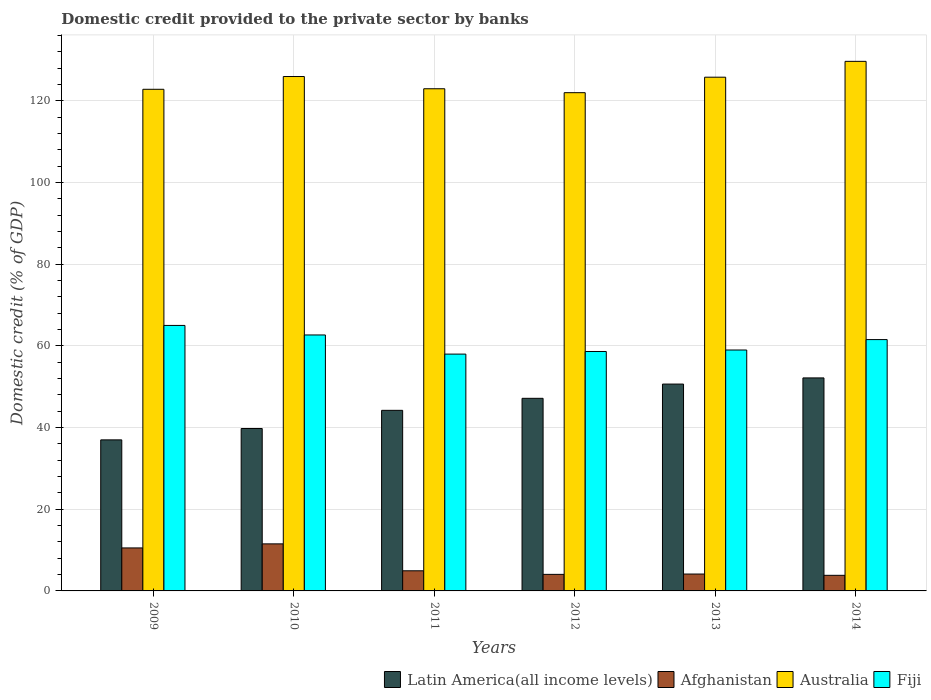How many bars are there on the 3rd tick from the left?
Offer a terse response. 4. What is the label of the 5th group of bars from the left?
Provide a short and direct response. 2013. In how many cases, is the number of bars for a given year not equal to the number of legend labels?
Give a very brief answer. 0. What is the domestic credit provided to the private sector by banks in Afghanistan in 2011?
Ensure brevity in your answer.  4.93. Across all years, what is the maximum domestic credit provided to the private sector by banks in Australia?
Your answer should be very brief. 129.64. Across all years, what is the minimum domestic credit provided to the private sector by banks in Latin America(all income levels)?
Your answer should be compact. 36.98. In which year was the domestic credit provided to the private sector by banks in Latin America(all income levels) maximum?
Offer a very short reply. 2014. What is the total domestic credit provided to the private sector by banks in Australia in the graph?
Ensure brevity in your answer.  749.01. What is the difference between the domestic credit provided to the private sector by banks in Latin America(all income levels) in 2010 and that in 2012?
Offer a very short reply. -7.39. What is the difference between the domestic credit provided to the private sector by banks in Afghanistan in 2011 and the domestic credit provided to the private sector by banks in Latin America(all income levels) in 2010?
Keep it short and to the point. -34.83. What is the average domestic credit provided to the private sector by banks in Fiji per year?
Keep it short and to the point. 60.79. In the year 2010, what is the difference between the domestic credit provided to the private sector by banks in Afghanistan and domestic credit provided to the private sector by banks in Latin America(all income levels)?
Your answer should be very brief. -28.24. What is the ratio of the domestic credit provided to the private sector by banks in Fiji in 2011 to that in 2014?
Your answer should be very brief. 0.94. Is the domestic credit provided to the private sector by banks in Afghanistan in 2009 less than that in 2010?
Offer a terse response. Yes. Is the difference between the domestic credit provided to the private sector by banks in Afghanistan in 2011 and 2014 greater than the difference between the domestic credit provided to the private sector by banks in Latin America(all income levels) in 2011 and 2014?
Give a very brief answer. Yes. What is the difference between the highest and the second highest domestic credit provided to the private sector by banks in Fiji?
Your answer should be very brief. 2.33. What is the difference between the highest and the lowest domestic credit provided to the private sector by banks in Latin America(all income levels)?
Give a very brief answer. 15.17. In how many years, is the domestic credit provided to the private sector by banks in Afghanistan greater than the average domestic credit provided to the private sector by banks in Afghanistan taken over all years?
Provide a short and direct response. 2. Is it the case that in every year, the sum of the domestic credit provided to the private sector by banks in Latin America(all income levels) and domestic credit provided to the private sector by banks in Australia is greater than the sum of domestic credit provided to the private sector by banks in Fiji and domestic credit provided to the private sector by banks in Afghanistan?
Ensure brevity in your answer.  Yes. What does the 2nd bar from the left in 2014 represents?
Your answer should be very brief. Afghanistan. What does the 4th bar from the right in 2009 represents?
Your answer should be very brief. Latin America(all income levels). Is it the case that in every year, the sum of the domestic credit provided to the private sector by banks in Australia and domestic credit provided to the private sector by banks in Afghanistan is greater than the domestic credit provided to the private sector by banks in Latin America(all income levels)?
Provide a short and direct response. Yes. How many bars are there?
Your response must be concise. 24. Are all the bars in the graph horizontal?
Your response must be concise. No. How many years are there in the graph?
Keep it short and to the point. 6. What is the difference between two consecutive major ticks on the Y-axis?
Make the answer very short. 20. Does the graph contain grids?
Provide a succinct answer. Yes. What is the title of the graph?
Ensure brevity in your answer.  Domestic credit provided to the private sector by banks. What is the label or title of the X-axis?
Keep it short and to the point. Years. What is the label or title of the Y-axis?
Your answer should be compact. Domestic credit (% of GDP). What is the Domestic credit (% of GDP) of Latin America(all income levels) in 2009?
Offer a terse response. 36.98. What is the Domestic credit (% of GDP) of Afghanistan in 2009?
Provide a short and direct response. 10.53. What is the Domestic credit (% of GDP) of Australia in 2009?
Provide a succinct answer. 122.8. What is the Domestic credit (% of GDP) in Fiji in 2009?
Your response must be concise. 64.99. What is the Domestic credit (% of GDP) in Latin America(all income levels) in 2010?
Your answer should be compact. 39.76. What is the Domestic credit (% of GDP) in Afghanistan in 2010?
Give a very brief answer. 11.52. What is the Domestic credit (% of GDP) of Australia in 2010?
Give a very brief answer. 125.92. What is the Domestic credit (% of GDP) of Fiji in 2010?
Your response must be concise. 62.66. What is the Domestic credit (% of GDP) in Latin America(all income levels) in 2011?
Give a very brief answer. 44.21. What is the Domestic credit (% of GDP) of Afghanistan in 2011?
Your response must be concise. 4.93. What is the Domestic credit (% of GDP) of Australia in 2011?
Ensure brevity in your answer.  122.93. What is the Domestic credit (% of GDP) of Fiji in 2011?
Keep it short and to the point. 57.97. What is the Domestic credit (% of GDP) of Latin America(all income levels) in 2012?
Make the answer very short. 47.15. What is the Domestic credit (% of GDP) in Afghanistan in 2012?
Offer a terse response. 4.05. What is the Domestic credit (% of GDP) of Australia in 2012?
Ensure brevity in your answer.  121.97. What is the Domestic credit (% of GDP) of Fiji in 2012?
Your answer should be compact. 58.61. What is the Domestic credit (% of GDP) in Latin America(all income levels) in 2013?
Provide a succinct answer. 50.63. What is the Domestic credit (% of GDP) in Afghanistan in 2013?
Provide a short and direct response. 4.13. What is the Domestic credit (% of GDP) of Australia in 2013?
Keep it short and to the point. 125.76. What is the Domestic credit (% of GDP) in Fiji in 2013?
Offer a terse response. 58.97. What is the Domestic credit (% of GDP) of Latin America(all income levels) in 2014?
Give a very brief answer. 52.14. What is the Domestic credit (% of GDP) in Afghanistan in 2014?
Ensure brevity in your answer.  3.82. What is the Domestic credit (% of GDP) of Australia in 2014?
Provide a succinct answer. 129.64. What is the Domestic credit (% of GDP) in Fiji in 2014?
Give a very brief answer. 61.52. Across all years, what is the maximum Domestic credit (% of GDP) in Latin America(all income levels)?
Your answer should be compact. 52.14. Across all years, what is the maximum Domestic credit (% of GDP) in Afghanistan?
Make the answer very short. 11.52. Across all years, what is the maximum Domestic credit (% of GDP) in Australia?
Ensure brevity in your answer.  129.64. Across all years, what is the maximum Domestic credit (% of GDP) of Fiji?
Provide a short and direct response. 64.99. Across all years, what is the minimum Domestic credit (% of GDP) in Latin America(all income levels)?
Give a very brief answer. 36.98. Across all years, what is the minimum Domestic credit (% of GDP) in Afghanistan?
Ensure brevity in your answer.  3.82. Across all years, what is the minimum Domestic credit (% of GDP) in Australia?
Keep it short and to the point. 121.97. Across all years, what is the minimum Domestic credit (% of GDP) of Fiji?
Your answer should be very brief. 57.97. What is the total Domestic credit (% of GDP) of Latin America(all income levels) in the graph?
Ensure brevity in your answer.  270.86. What is the total Domestic credit (% of GDP) in Afghanistan in the graph?
Your answer should be very brief. 38.98. What is the total Domestic credit (% of GDP) of Australia in the graph?
Provide a succinct answer. 749.01. What is the total Domestic credit (% of GDP) in Fiji in the graph?
Your response must be concise. 364.73. What is the difference between the Domestic credit (% of GDP) of Latin America(all income levels) in 2009 and that in 2010?
Provide a succinct answer. -2.78. What is the difference between the Domestic credit (% of GDP) of Afghanistan in 2009 and that in 2010?
Provide a short and direct response. -0.99. What is the difference between the Domestic credit (% of GDP) of Australia in 2009 and that in 2010?
Provide a succinct answer. -3.13. What is the difference between the Domestic credit (% of GDP) of Fiji in 2009 and that in 2010?
Provide a short and direct response. 2.33. What is the difference between the Domestic credit (% of GDP) in Latin America(all income levels) in 2009 and that in 2011?
Your response must be concise. -7.23. What is the difference between the Domestic credit (% of GDP) in Afghanistan in 2009 and that in 2011?
Offer a very short reply. 5.6. What is the difference between the Domestic credit (% of GDP) of Australia in 2009 and that in 2011?
Offer a very short reply. -0.13. What is the difference between the Domestic credit (% of GDP) in Fiji in 2009 and that in 2011?
Offer a very short reply. 7.02. What is the difference between the Domestic credit (% of GDP) of Latin America(all income levels) in 2009 and that in 2012?
Provide a succinct answer. -10.17. What is the difference between the Domestic credit (% of GDP) in Afghanistan in 2009 and that in 2012?
Keep it short and to the point. 6.47. What is the difference between the Domestic credit (% of GDP) in Australia in 2009 and that in 2012?
Give a very brief answer. 0.83. What is the difference between the Domestic credit (% of GDP) of Fiji in 2009 and that in 2012?
Ensure brevity in your answer.  6.38. What is the difference between the Domestic credit (% of GDP) of Latin America(all income levels) in 2009 and that in 2013?
Keep it short and to the point. -13.66. What is the difference between the Domestic credit (% of GDP) in Afghanistan in 2009 and that in 2013?
Provide a short and direct response. 6.39. What is the difference between the Domestic credit (% of GDP) of Australia in 2009 and that in 2013?
Give a very brief answer. -2.96. What is the difference between the Domestic credit (% of GDP) of Fiji in 2009 and that in 2013?
Your response must be concise. 6.02. What is the difference between the Domestic credit (% of GDP) of Latin America(all income levels) in 2009 and that in 2014?
Provide a short and direct response. -15.17. What is the difference between the Domestic credit (% of GDP) of Afghanistan in 2009 and that in 2014?
Keep it short and to the point. 6.71. What is the difference between the Domestic credit (% of GDP) of Australia in 2009 and that in 2014?
Give a very brief answer. -6.84. What is the difference between the Domestic credit (% of GDP) in Fiji in 2009 and that in 2014?
Give a very brief answer. 3.47. What is the difference between the Domestic credit (% of GDP) of Latin America(all income levels) in 2010 and that in 2011?
Ensure brevity in your answer.  -4.45. What is the difference between the Domestic credit (% of GDP) of Afghanistan in 2010 and that in 2011?
Your answer should be very brief. 6.59. What is the difference between the Domestic credit (% of GDP) of Australia in 2010 and that in 2011?
Offer a very short reply. 3. What is the difference between the Domestic credit (% of GDP) in Fiji in 2010 and that in 2011?
Offer a terse response. 4.68. What is the difference between the Domestic credit (% of GDP) in Latin America(all income levels) in 2010 and that in 2012?
Your answer should be compact. -7.39. What is the difference between the Domestic credit (% of GDP) of Afghanistan in 2010 and that in 2012?
Your answer should be very brief. 7.46. What is the difference between the Domestic credit (% of GDP) of Australia in 2010 and that in 2012?
Your answer should be very brief. 3.95. What is the difference between the Domestic credit (% of GDP) in Fiji in 2010 and that in 2012?
Your answer should be very brief. 4.05. What is the difference between the Domestic credit (% of GDP) in Latin America(all income levels) in 2010 and that in 2013?
Provide a succinct answer. -10.88. What is the difference between the Domestic credit (% of GDP) in Afghanistan in 2010 and that in 2013?
Your answer should be very brief. 7.39. What is the difference between the Domestic credit (% of GDP) of Australia in 2010 and that in 2013?
Your answer should be compact. 0.16. What is the difference between the Domestic credit (% of GDP) in Fiji in 2010 and that in 2013?
Provide a short and direct response. 3.68. What is the difference between the Domestic credit (% of GDP) in Latin America(all income levels) in 2010 and that in 2014?
Provide a short and direct response. -12.39. What is the difference between the Domestic credit (% of GDP) in Afghanistan in 2010 and that in 2014?
Offer a terse response. 7.7. What is the difference between the Domestic credit (% of GDP) in Australia in 2010 and that in 2014?
Offer a terse response. -3.71. What is the difference between the Domestic credit (% of GDP) in Fiji in 2010 and that in 2014?
Keep it short and to the point. 1.13. What is the difference between the Domestic credit (% of GDP) in Latin America(all income levels) in 2011 and that in 2012?
Provide a short and direct response. -2.94. What is the difference between the Domestic credit (% of GDP) of Australia in 2011 and that in 2012?
Keep it short and to the point. 0.96. What is the difference between the Domestic credit (% of GDP) in Fiji in 2011 and that in 2012?
Your answer should be compact. -0.64. What is the difference between the Domestic credit (% of GDP) of Latin America(all income levels) in 2011 and that in 2013?
Your response must be concise. -6.43. What is the difference between the Domestic credit (% of GDP) in Afghanistan in 2011 and that in 2013?
Keep it short and to the point. 0.8. What is the difference between the Domestic credit (% of GDP) of Australia in 2011 and that in 2013?
Your answer should be very brief. -2.83. What is the difference between the Domestic credit (% of GDP) of Fiji in 2011 and that in 2013?
Ensure brevity in your answer.  -1. What is the difference between the Domestic credit (% of GDP) of Latin America(all income levels) in 2011 and that in 2014?
Make the answer very short. -7.94. What is the difference between the Domestic credit (% of GDP) in Afghanistan in 2011 and that in 2014?
Your response must be concise. 1.11. What is the difference between the Domestic credit (% of GDP) in Australia in 2011 and that in 2014?
Provide a succinct answer. -6.71. What is the difference between the Domestic credit (% of GDP) of Fiji in 2011 and that in 2014?
Your response must be concise. -3.55. What is the difference between the Domestic credit (% of GDP) of Latin America(all income levels) in 2012 and that in 2013?
Your response must be concise. -3.49. What is the difference between the Domestic credit (% of GDP) of Afghanistan in 2012 and that in 2013?
Your answer should be very brief. -0.08. What is the difference between the Domestic credit (% of GDP) in Australia in 2012 and that in 2013?
Make the answer very short. -3.79. What is the difference between the Domestic credit (% of GDP) of Fiji in 2012 and that in 2013?
Provide a succinct answer. -0.36. What is the difference between the Domestic credit (% of GDP) of Latin America(all income levels) in 2012 and that in 2014?
Offer a very short reply. -5. What is the difference between the Domestic credit (% of GDP) of Afghanistan in 2012 and that in 2014?
Provide a short and direct response. 0.24. What is the difference between the Domestic credit (% of GDP) in Australia in 2012 and that in 2014?
Make the answer very short. -7.67. What is the difference between the Domestic credit (% of GDP) of Fiji in 2012 and that in 2014?
Ensure brevity in your answer.  -2.91. What is the difference between the Domestic credit (% of GDP) of Latin America(all income levels) in 2013 and that in 2014?
Offer a terse response. -1.51. What is the difference between the Domestic credit (% of GDP) in Afghanistan in 2013 and that in 2014?
Your answer should be very brief. 0.31. What is the difference between the Domestic credit (% of GDP) in Australia in 2013 and that in 2014?
Provide a succinct answer. -3.88. What is the difference between the Domestic credit (% of GDP) in Fiji in 2013 and that in 2014?
Keep it short and to the point. -2.55. What is the difference between the Domestic credit (% of GDP) of Latin America(all income levels) in 2009 and the Domestic credit (% of GDP) of Afghanistan in 2010?
Your answer should be compact. 25.46. What is the difference between the Domestic credit (% of GDP) of Latin America(all income levels) in 2009 and the Domestic credit (% of GDP) of Australia in 2010?
Your answer should be compact. -88.95. What is the difference between the Domestic credit (% of GDP) of Latin America(all income levels) in 2009 and the Domestic credit (% of GDP) of Fiji in 2010?
Your answer should be very brief. -25.68. What is the difference between the Domestic credit (% of GDP) of Afghanistan in 2009 and the Domestic credit (% of GDP) of Australia in 2010?
Provide a succinct answer. -115.4. What is the difference between the Domestic credit (% of GDP) of Afghanistan in 2009 and the Domestic credit (% of GDP) of Fiji in 2010?
Provide a short and direct response. -52.13. What is the difference between the Domestic credit (% of GDP) of Australia in 2009 and the Domestic credit (% of GDP) of Fiji in 2010?
Keep it short and to the point. 60.14. What is the difference between the Domestic credit (% of GDP) of Latin America(all income levels) in 2009 and the Domestic credit (% of GDP) of Afghanistan in 2011?
Make the answer very short. 32.05. What is the difference between the Domestic credit (% of GDP) of Latin America(all income levels) in 2009 and the Domestic credit (% of GDP) of Australia in 2011?
Keep it short and to the point. -85.95. What is the difference between the Domestic credit (% of GDP) in Latin America(all income levels) in 2009 and the Domestic credit (% of GDP) in Fiji in 2011?
Your response must be concise. -21. What is the difference between the Domestic credit (% of GDP) in Afghanistan in 2009 and the Domestic credit (% of GDP) in Australia in 2011?
Offer a terse response. -112.4. What is the difference between the Domestic credit (% of GDP) of Afghanistan in 2009 and the Domestic credit (% of GDP) of Fiji in 2011?
Provide a short and direct response. -47.45. What is the difference between the Domestic credit (% of GDP) in Australia in 2009 and the Domestic credit (% of GDP) in Fiji in 2011?
Provide a succinct answer. 64.82. What is the difference between the Domestic credit (% of GDP) in Latin America(all income levels) in 2009 and the Domestic credit (% of GDP) in Afghanistan in 2012?
Offer a terse response. 32.92. What is the difference between the Domestic credit (% of GDP) in Latin America(all income levels) in 2009 and the Domestic credit (% of GDP) in Australia in 2012?
Your answer should be compact. -84.99. What is the difference between the Domestic credit (% of GDP) of Latin America(all income levels) in 2009 and the Domestic credit (% of GDP) of Fiji in 2012?
Offer a terse response. -21.63. What is the difference between the Domestic credit (% of GDP) of Afghanistan in 2009 and the Domestic credit (% of GDP) of Australia in 2012?
Your answer should be very brief. -111.44. What is the difference between the Domestic credit (% of GDP) in Afghanistan in 2009 and the Domestic credit (% of GDP) in Fiji in 2012?
Make the answer very short. -48.08. What is the difference between the Domestic credit (% of GDP) in Australia in 2009 and the Domestic credit (% of GDP) in Fiji in 2012?
Offer a very short reply. 64.19. What is the difference between the Domestic credit (% of GDP) in Latin America(all income levels) in 2009 and the Domestic credit (% of GDP) in Afghanistan in 2013?
Your answer should be compact. 32.84. What is the difference between the Domestic credit (% of GDP) in Latin America(all income levels) in 2009 and the Domestic credit (% of GDP) in Australia in 2013?
Offer a very short reply. -88.78. What is the difference between the Domestic credit (% of GDP) of Latin America(all income levels) in 2009 and the Domestic credit (% of GDP) of Fiji in 2013?
Offer a terse response. -22. What is the difference between the Domestic credit (% of GDP) in Afghanistan in 2009 and the Domestic credit (% of GDP) in Australia in 2013?
Your answer should be compact. -115.23. What is the difference between the Domestic credit (% of GDP) in Afghanistan in 2009 and the Domestic credit (% of GDP) in Fiji in 2013?
Give a very brief answer. -48.45. What is the difference between the Domestic credit (% of GDP) in Australia in 2009 and the Domestic credit (% of GDP) in Fiji in 2013?
Your answer should be very brief. 63.82. What is the difference between the Domestic credit (% of GDP) in Latin America(all income levels) in 2009 and the Domestic credit (% of GDP) in Afghanistan in 2014?
Ensure brevity in your answer.  33.16. What is the difference between the Domestic credit (% of GDP) in Latin America(all income levels) in 2009 and the Domestic credit (% of GDP) in Australia in 2014?
Offer a terse response. -92.66. What is the difference between the Domestic credit (% of GDP) in Latin America(all income levels) in 2009 and the Domestic credit (% of GDP) in Fiji in 2014?
Your answer should be very brief. -24.55. What is the difference between the Domestic credit (% of GDP) of Afghanistan in 2009 and the Domestic credit (% of GDP) of Australia in 2014?
Your response must be concise. -119.11. What is the difference between the Domestic credit (% of GDP) of Afghanistan in 2009 and the Domestic credit (% of GDP) of Fiji in 2014?
Ensure brevity in your answer.  -51. What is the difference between the Domestic credit (% of GDP) of Australia in 2009 and the Domestic credit (% of GDP) of Fiji in 2014?
Provide a short and direct response. 61.27. What is the difference between the Domestic credit (% of GDP) of Latin America(all income levels) in 2010 and the Domestic credit (% of GDP) of Afghanistan in 2011?
Provide a succinct answer. 34.83. What is the difference between the Domestic credit (% of GDP) of Latin America(all income levels) in 2010 and the Domestic credit (% of GDP) of Australia in 2011?
Provide a succinct answer. -83.17. What is the difference between the Domestic credit (% of GDP) in Latin America(all income levels) in 2010 and the Domestic credit (% of GDP) in Fiji in 2011?
Your answer should be compact. -18.22. What is the difference between the Domestic credit (% of GDP) in Afghanistan in 2010 and the Domestic credit (% of GDP) in Australia in 2011?
Your answer should be compact. -111.41. What is the difference between the Domestic credit (% of GDP) of Afghanistan in 2010 and the Domestic credit (% of GDP) of Fiji in 2011?
Your response must be concise. -46.46. What is the difference between the Domestic credit (% of GDP) in Australia in 2010 and the Domestic credit (% of GDP) in Fiji in 2011?
Your answer should be compact. 67.95. What is the difference between the Domestic credit (% of GDP) in Latin America(all income levels) in 2010 and the Domestic credit (% of GDP) in Afghanistan in 2012?
Your answer should be very brief. 35.7. What is the difference between the Domestic credit (% of GDP) of Latin America(all income levels) in 2010 and the Domestic credit (% of GDP) of Australia in 2012?
Provide a succinct answer. -82.21. What is the difference between the Domestic credit (% of GDP) in Latin America(all income levels) in 2010 and the Domestic credit (% of GDP) in Fiji in 2012?
Ensure brevity in your answer.  -18.85. What is the difference between the Domestic credit (% of GDP) in Afghanistan in 2010 and the Domestic credit (% of GDP) in Australia in 2012?
Make the answer very short. -110.45. What is the difference between the Domestic credit (% of GDP) of Afghanistan in 2010 and the Domestic credit (% of GDP) of Fiji in 2012?
Provide a succinct answer. -47.09. What is the difference between the Domestic credit (% of GDP) of Australia in 2010 and the Domestic credit (% of GDP) of Fiji in 2012?
Give a very brief answer. 67.31. What is the difference between the Domestic credit (% of GDP) in Latin America(all income levels) in 2010 and the Domestic credit (% of GDP) in Afghanistan in 2013?
Offer a very short reply. 35.62. What is the difference between the Domestic credit (% of GDP) of Latin America(all income levels) in 2010 and the Domestic credit (% of GDP) of Australia in 2013?
Your response must be concise. -86. What is the difference between the Domestic credit (% of GDP) of Latin America(all income levels) in 2010 and the Domestic credit (% of GDP) of Fiji in 2013?
Make the answer very short. -19.22. What is the difference between the Domestic credit (% of GDP) of Afghanistan in 2010 and the Domestic credit (% of GDP) of Australia in 2013?
Your answer should be very brief. -114.24. What is the difference between the Domestic credit (% of GDP) in Afghanistan in 2010 and the Domestic credit (% of GDP) in Fiji in 2013?
Keep it short and to the point. -47.46. What is the difference between the Domestic credit (% of GDP) of Australia in 2010 and the Domestic credit (% of GDP) of Fiji in 2013?
Keep it short and to the point. 66.95. What is the difference between the Domestic credit (% of GDP) in Latin America(all income levels) in 2010 and the Domestic credit (% of GDP) in Afghanistan in 2014?
Offer a terse response. 35.94. What is the difference between the Domestic credit (% of GDP) of Latin America(all income levels) in 2010 and the Domestic credit (% of GDP) of Australia in 2014?
Your answer should be compact. -89.88. What is the difference between the Domestic credit (% of GDP) of Latin America(all income levels) in 2010 and the Domestic credit (% of GDP) of Fiji in 2014?
Provide a succinct answer. -21.77. What is the difference between the Domestic credit (% of GDP) of Afghanistan in 2010 and the Domestic credit (% of GDP) of Australia in 2014?
Your answer should be very brief. -118.12. What is the difference between the Domestic credit (% of GDP) in Afghanistan in 2010 and the Domestic credit (% of GDP) in Fiji in 2014?
Provide a succinct answer. -50.01. What is the difference between the Domestic credit (% of GDP) in Australia in 2010 and the Domestic credit (% of GDP) in Fiji in 2014?
Your answer should be compact. 64.4. What is the difference between the Domestic credit (% of GDP) of Latin America(all income levels) in 2011 and the Domestic credit (% of GDP) of Afghanistan in 2012?
Provide a short and direct response. 40.15. What is the difference between the Domestic credit (% of GDP) of Latin America(all income levels) in 2011 and the Domestic credit (% of GDP) of Australia in 2012?
Give a very brief answer. -77.76. What is the difference between the Domestic credit (% of GDP) in Latin America(all income levels) in 2011 and the Domestic credit (% of GDP) in Fiji in 2012?
Ensure brevity in your answer.  -14.4. What is the difference between the Domestic credit (% of GDP) of Afghanistan in 2011 and the Domestic credit (% of GDP) of Australia in 2012?
Ensure brevity in your answer.  -117.04. What is the difference between the Domestic credit (% of GDP) in Afghanistan in 2011 and the Domestic credit (% of GDP) in Fiji in 2012?
Ensure brevity in your answer.  -53.68. What is the difference between the Domestic credit (% of GDP) of Australia in 2011 and the Domestic credit (% of GDP) of Fiji in 2012?
Keep it short and to the point. 64.32. What is the difference between the Domestic credit (% of GDP) in Latin America(all income levels) in 2011 and the Domestic credit (% of GDP) in Afghanistan in 2013?
Provide a short and direct response. 40.08. What is the difference between the Domestic credit (% of GDP) in Latin America(all income levels) in 2011 and the Domestic credit (% of GDP) in Australia in 2013?
Your answer should be compact. -81.55. What is the difference between the Domestic credit (% of GDP) in Latin America(all income levels) in 2011 and the Domestic credit (% of GDP) in Fiji in 2013?
Give a very brief answer. -14.77. What is the difference between the Domestic credit (% of GDP) in Afghanistan in 2011 and the Domestic credit (% of GDP) in Australia in 2013?
Give a very brief answer. -120.83. What is the difference between the Domestic credit (% of GDP) in Afghanistan in 2011 and the Domestic credit (% of GDP) in Fiji in 2013?
Your answer should be very brief. -54.04. What is the difference between the Domestic credit (% of GDP) of Australia in 2011 and the Domestic credit (% of GDP) of Fiji in 2013?
Your answer should be compact. 63.95. What is the difference between the Domestic credit (% of GDP) in Latin America(all income levels) in 2011 and the Domestic credit (% of GDP) in Afghanistan in 2014?
Your response must be concise. 40.39. What is the difference between the Domestic credit (% of GDP) in Latin America(all income levels) in 2011 and the Domestic credit (% of GDP) in Australia in 2014?
Provide a succinct answer. -85.43. What is the difference between the Domestic credit (% of GDP) of Latin America(all income levels) in 2011 and the Domestic credit (% of GDP) of Fiji in 2014?
Keep it short and to the point. -17.32. What is the difference between the Domestic credit (% of GDP) of Afghanistan in 2011 and the Domestic credit (% of GDP) of Australia in 2014?
Offer a terse response. -124.71. What is the difference between the Domestic credit (% of GDP) of Afghanistan in 2011 and the Domestic credit (% of GDP) of Fiji in 2014?
Offer a very short reply. -56.59. What is the difference between the Domestic credit (% of GDP) in Australia in 2011 and the Domestic credit (% of GDP) in Fiji in 2014?
Offer a very short reply. 61.4. What is the difference between the Domestic credit (% of GDP) of Latin America(all income levels) in 2012 and the Domestic credit (% of GDP) of Afghanistan in 2013?
Your answer should be very brief. 43.01. What is the difference between the Domestic credit (% of GDP) of Latin America(all income levels) in 2012 and the Domestic credit (% of GDP) of Australia in 2013?
Provide a short and direct response. -78.61. What is the difference between the Domestic credit (% of GDP) of Latin America(all income levels) in 2012 and the Domestic credit (% of GDP) of Fiji in 2013?
Ensure brevity in your answer.  -11.83. What is the difference between the Domestic credit (% of GDP) in Afghanistan in 2012 and the Domestic credit (% of GDP) in Australia in 2013?
Offer a terse response. -121.7. What is the difference between the Domestic credit (% of GDP) of Afghanistan in 2012 and the Domestic credit (% of GDP) of Fiji in 2013?
Give a very brief answer. -54.92. What is the difference between the Domestic credit (% of GDP) of Australia in 2012 and the Domestic credit (% of GDP) of Fiji in 2013?
Your answer should be compact. 62.99. What is the difference between the Domestic credit (% of GDP) of Latin America(all income levels) in 2012 and the Domestic credit (% of GDP) of Afghanistan in 2014?
Your answer should be very brief. 43.33. What is the difference between the Domestic credit (% of GDP) in Latin America(all income levels) in 2012 and the Domestic credit (% of GDP) in Australia in 2014?
Provide a succinct answer. -82.49. What is the difference between the Domestic credit (% of GDP) in Latin America(all income levels) in 2012 and the Domestic credit (% of GDP) in Fiji in 2014?
Make the answer very short. -14.38. What is the difference between the Domestic credit (% of GDP) of Afghanistan in 2012 and the Domestic credit (% of GDP) of Australia in 2014?
Your answer should be compact. -125.58. What is the difference between the Domestic credit (% of GDP) of Afghanistan in 2012 and the Domestic credit (% of GDP) of Fiji in 2014?
Offer a very short reply. -57.47. What is the difference between the Domestic credit (% of GDP) in Australia in 2012 and the Domestic credit (% of GDP) in Fiji in 2014?
Ensure brevity in your answer.  60.44. What is the difference between the Domestic credit (% of GDP) in Latin America(all income levels) in 2013 and the Domestic credit (% of GDP) in Afghanistan in 2014?
Your answer should be compact. 46.82. What is the difference between the Domestic credit (% of GDP) of Latin America(all income levels) in 2013 and the Domestic credit (% of GDP) of Australia in 2014?
Provide a succinct answer. -79. What is the difference between the Domestic credit (% of GDP) in Latin America(all income levels) in 2013 and the Domestic credit (% of GDP) in Fiji in 2014?
Offer a very short reply. -10.89. What is the difference between the Domestic credit (% of GDP) of Afghanistan in 2013 and the Domestic credit (% of GDP) of Australia in 2014?
Ensure brevity in your answer.  -125.5. What is the difference between the Domestic credit (% of GDP) in Afghanistan in 2013 and the Domestic credit (% of GDP) in Fiji in 2014?
Offer a very short reply. -57.39. What is the difference between the Domestic credit (% of GDP) in Australia in 2013 and the Domestic credit (% of GDP) in Fiji in 2014?
Offer a terse response. 64.23. What is the average Domestic credit (% of GDP) of Latin America(all income levels) per year?
Ensure brevity in your answer.  45.14. What is the average Domestic credit (% of GDP) in Afghanistan per year?
Your response must be concise. 6.5. What is the average Domestic credit (% of GDP) of Australia per year?
Provide a short and direct response. 124.83. What is the average Domestic credit (% of GDP) of Fiji per year?
Offer a terse response. 60.79. In the year 2009, what is the difference between the Domestic credit (% of GDP) in Latin America(all income levels) and Domestic credit (% of GDP) in Afghanistan?
Your answer should be compact. 26.45. In the year 2009, what is the difference between the Domestic credit (% of GDP) in Latin America(all income levels) and Domestic credit (% of GDP) in Australia?
Offer a very short reply. -85.82. In the year 2009, what is the difference between the Domestic credit (% of GDP) in Latin America(all income levels) and Domestic credit (% of GDP) in Fiji?
Give a very brief answer. -28.02. In the year 2009, what is the difference between the Domestic credit (% of GDP) of Afghanistan and Domestic credit (% of GDP) of Australia?
Make the answer very short. -112.27. In the year 2009, what is the difference between the Domestic credit (% of GDP) in Afghanistan and Domestic credit (% of GDP) in Fiji?
Give a very brief answer. -54.47. In the year 2009, what is the difference between the Domestic credit (% of GDP) in Australia and Domestic credit (% of GDP) in Fiji?
Your answer should be compact. 57.81. In the year 2010, what is the difference between the Domestic credit (% of GDP) in Latin America(all income levels) and Domestic credit (% of GDP) in Afghanistan?
Ensure brevity in your answer.  28.24. In the year 2010, what is the difference between the Domestic credit (% of GDP) in Latin America(all income levels) and Domestic credit (% of GDP) in Australia?
Make the answer very short. -86.17. In the year 2010, what is the difference between the Domestic credit (% of GDP) in Latin America(all income levels) and Domestic credit (% of GDP) in Fiji?
Your answer should be very brief. -22.9. In the year 2010, what is the difference between the Domestic credit (% of GDP) of Afghanistan and Domestic credit (% of GDP) of Australia?
Keep it short and to the point. -114.41. In the year 2010, what is the difference between the Domestic credit (% of GDP) in Afghanistan and Domestic credit (% of GDP) in Fiji?
Your answer should be compact. -51.14. In the year 2010, what is the difference between the Domestic credit (% of GDP) in Australia and Domestic credit (% of GDP) in Fiji?
Your answer should be very brief. 63.26. In the year 2011, what is the difference between the Domestic credit (% of GDP) in Latin America(all income levels) and Domestic credit (% of GDP) in Afghanistan?
Offer a very short reply. 39.28. In the year 2011, what is the difference between the Domestic credit (% of GDP) of Latin America(all income levels) and Domestic credit (% of GDP) of Australia?
Provide a succinct answer. -78.72. In the year 2011, what is the difference between the Domestic credit (% of GDP) in Latin America(all income levels) and Domestic credit (% of GDP) in Fiji?
Give a very brief answer. -13.77. In the year 2011, what is the difference between the Domestic credit (% of GDP) in Afghanistan and Domestic credit (% of GDP) in Australia?
Your response must be concise. -118. In the year 2011, what is the difference between the Domestic credit (% of GDP) in Afghanistan and Domestic credit (% of GDP) in Fiji?
Offer a terse response. -53.04. In the year 2011, what is the difference between the Domestic credit (% of GDP) in Australia and Domestic credit (% of GDP) in Fiji?
Offer a very short reply. 64.95. In the year 2012, what is the difference between the Domestic credit (% of GDP) in Latin America(all income levels) and Domestic credit (% of GDP) in Afghanistan?
Offer a terse response. 43.09. In the year 2012, what is the difference between the Domestic credit (% of GDP) in Latin America(all income levels) and Domestic credit (% of GDP) in Australia?
Make the answer very short. -74.82. In the year 2012, what is the difference between the Domestic credit (% of GDP) of Latin America(all income levels) and Domestic credit (% of GDP) of Fiji?
Offer a terse response. -11.46. In the year 2012, what is the difference between the Domestic credit (% of GDP) in Afghanistan and Domestic credit (% of GDP) in Australia?
Provide a succinct answer. -117.91. In the year 2012, what is the difference between the Domestic credit (% of GDP) of Afghanistan and Domestic credit (% of GDP) of Fiji?
Your response must be concise. -54.56. In the year 2012, what is the difference between the Domestic credit (% of GDP) in Australia and Domestic credit (% of GDP) in Fiji?
Your answer should be very brief. 63.36. In the year 2013, what is the difference between the Domestic credit (% of GDP) of Latin America(all income levels) and Domestic credit (% of GDP) of Afghanistan?
Provide a short and direct response. 46.5. In the year 2013, what is the difference between the Domestic credit (% of GDP) of Latin America(all income levels) and Domestic credit (% of GDP) of Australia?
Provide a short and direct response. -75.12. In the year 2013, what is the difference between the Domestic credit (% of GDP) in Latin America(all income levels) and Domestic credit (% of GDP) in Fiji?
Provide a short and direct response. -8.34. In the year 2013, what is the difference between the Domestic credit (% of GDP) in Afghanistan and Domestic credit (% of GDP) in Australia?
Your response must be concise. -121.63. In the year 2013, what is the difference between the Domestic credit (% of GDP) in Afghanistan and Domestic credit (% of GDP) in Fiji?
Ensure brevity in your answer.  -54.84. In the year 2013, what is the difference between the Domestic credit (% of GDP) in Australia and Domestic credit (% of GDP) in Fiji?
Give a very brief answer. 66.78. In the year 2014, what is the difference between the Domestic credit (% of GDP) in Latin America(all income levels) and Domestic credit (% of GDP) in Afghanistan?
Your answer should be very brief. 48.33. In the year 2014, what is the difference between the Domestic credit (% of GDP) of Latin America(all income levels) and Domestic credit (% of GDP) of Australia?
Provide a succinct answer. -77.49. In the year 2014, what is the difference between the Domestic credit (% of GDP) in Latin America(all income levels) and Domestic credit (% of GDP) in Fiji?
Provide a succinct answer. -9.38. In the year 2014, what is the difference between the Domestic credit (% of GDP) in Afghanistan and Domestic credit (% of GDP) in Australia?
Make the answer very short. -125.82. In the year 2014, what is the difference between the Domestic credit (% of GDP) of Afghanistan and Domestic credit (% of GDP) of Fiji?
Offer a very short reply. -57.71. In the year 2014, what is the difference between the Domestic credit (% of GDP) in Australia and Domestic credit (% of GDP) in Fiji?
Give a very brief answer. 68.11. What is the ratio of the Domestic credit (% of GDP) in Latin America(all income levels) in 2009 to that in 2010?
Keep it short and to the point. 0.93. What is the ratio of the Domestic credit (% of GDP) of Afghanistan in 2009 to that in 2010?
Your answer should be compact. 0.91. What is the ratio of the Domestic credit (% of GDP) of Australia in 2009 to that in 2010?
Provide a short and direct response. 0.98. What is the ratio of the Domestic credit (% of GDP) of Fiji in 2009 to that in 2010?
Ensure brevity in your answer.  1.04. What is the ratio of the Domestic credit (% of GDP) in Latin America(all income levels) in 2009 to that in 2011?
Ensure brevity in your answer.  0.84. What is the ratio of the Domestic credit (% of GDP) in Afghanistan in 2009 to that in 2011?
Offer a terse response. 2.14. What is the ratio of the Domestic credit (% of GDP) in Fiji in 2009 to that in 2011?
Your answer should be compact. 1.12. What is the ratio of the Domestic credit (% of GDP) in Latin America(all income levels) in 2009 to that in 2012?
Offer a very short reply. 0.78. What is the ratio of the Domestic credit (% of GDP) in Afghanistan in 2009 to that in 2012?
Ensure brevity in your answer.  2.6. What is the ratio of the Domestic credit (% of GDP) of Australia in 2009 to that in 2012?
Your response must be concise. 1.01. What is the ratio of the Domestic credit (% of GDP) of Fiji in 2009 to that in 2012?
Keep it short and to the point. 1.11. What is the ratio of the Domestic credit (% of GDP) of Latin America(all income levels) in 2009 to that in 2013?
Keep it short and to the point. 0.73. What is the ratio of the Domestic credit (% of GDP) of Afghanistan in 2009 to that in 2013?
Ensure brevity in your answer.  2.55. What is the ratio of the Domestic credit (% of GDP) in Australia in 2009 to that in 2013?
Provide a succinct answer. 0.98. What is the ratio of the Domestic credit (% of GDP) of Fiji in 2009 to that in 2013?
Offer a very short reply. 1.1. What is the ratio of the Domestic credit (% of GDP) in Latin America(all income levels) in 2009 to that in 2014?
Provide a succinct answer. 0.71. What is the ratio of the Domestic credit (% of GDP) of Afghanistan in 2009 to that in 2014?
Offer a very short reply. 2.76. What is the ratio of the Domestic credit (% of GDP) in Australia in 2009 to that in 2014?
Keep it short and to the point. 0.95. What is the ratio of the Domestic credit (% of GDP) of Fiji in 2009 to that in 2014?
Offer a terse response. 1.06. What is the ratio of the Domestic credit (% of GDP) of Latin America(all income levels) in 2010 to that in 2011?
Give a very brief answer. 0.9. What is the ratio of the Domestic credit (% of GDP) of Afghanistan in 2010 to that in 2011?
Ensure brevity in your answer.  2.34. What is the ratio of the Domestic credit (% of GDP) in Australia in 2010 to that in 2011?
Keep it short and to the point. 1.02. What is the ratio of the Domestic credit (% of GDP) in Fiji in 2010 to that in 2011?
Your response must be concise. 1.08. What is the ratio of the Domestic credit (% of GDP) of Latin America(all income levels) in 2010 to that in 2012?
Ensure brevity in your answer.  0.84. What is the ratio of the Domestic credit (% of GDP) in Afghanistan in 2010 to that in 2012?
Offer a terse response. 2.84. What is the ratio of the Domestic credit (% of GDP) of Australia in 2010 to that in 2012?
Give a very brief answer. 1.03. What is the ratio of the Domestic credit (% of GDP) of Fiji in 2010 to that in 2012?
Provide a short and direct response. 1.07. What is the ratio of the Domestic credit (% of GDP) in Latin America(all income levels) in 2010 to that in 2013?
Provide a succinct answer. 0.79. What is the ratio of the Domestic credit (% of GDP) in Afghanistan in 2010 to that in 2013?
Offer a very short reply. 2.79. What is the ratio of the Domestic credit (% of GDP) in Australia in 2010 to that in 2013?
Ensure brevity in your answer.  1. What is the ratio of the Domestic credit (% of GDP) of Latin America(all income levels) in 2010 to that in 2014?
Provide a succinct answer. 0.76. What is the ratio of the Domestic credit (% of GDP) of Afghanistan in 2010 to that in 2014?
Provide a short and direct response. 3.02. What is the ratio of the Domestic credit (% of GDP) in Australia in 2010 to that in 2014?
Your answer should be compact. 0.97. What is the ratio of the Domestic credit (% of GDP) of Fiji in 2010 to that in 2014?
Keep it short and to the point. 1.02. What is the ratio of the Domestic credit (% of GDP) of Latin America(all income levels) in 2011 to that in 2012?
Make the answer very short. 0.94. What is the ratio of the Domestic credit (% of GDP) in Afghanistan in 2011 to that in 2012?
Give a very brief answer. 1.22. What is the ratio of the Domestic credit (% of GDP) in Australia in 2011 to that in 2012?
Your response must be concise. 1.01. What is the ratio of the Domestic credit (% of GDP) in Fiji in 2011 to that in 2012?
Offer a terse response. 0.99. What is the ratio of the Domestic credit (% of GDP) in Latin America(all income levels) in 2011 to that in 2013?
Your response must be concise. 0.87. What is the ratio of the Domestic credit (% of GDP) of Afghanistan in 2011 to that in 2013?
Offer a very short reply. 1.19. What is the ratio of the Domestic credit (% of GDP) of Australia in 2011 to that in 2013?
Make the answer very short. 0.98. What is the ratio of the Domestic credit (% of GDP) of Latin America(all income levels) in 2011 to that in 2014?
Offer a very short reply. 0.85. What is the ratio of the Domestic credit (% of GDP) of Afghanistan in 2011 to that in 2014?
Offer a very short reply. 1.29. What is the ratio of the Domestic credit (% of GDP) of Australia in 2011 to that in 2014?
Ensure brevity in your answer.  0.95. What is the ratio of the Domestic credit (% of GDP) in Fiji in 2011 to that in 2014?
Provide a succinct answer. 0.94. What is the ratio of the Domestic credit (% of GDP) of Latin America(all income levels) in 2012 to that in 2013?
Your answer should be compact. 0.93. What is the ratio of the Domestic credit (% of GDP) of Afghanistan in 2012 to that in 2013?
Your response must be concise. 0.98. What is the ratio of the Domestic credit (% of GDP) in Australia in 2012 to that in 2013?
Your response must be concise. 0.97. What is the ratio of the Domestic credit (% of GDP) in Fiji in 2012 to that in 2013?
Provide a short and direct response. 0.99. What is the ratio of the Domestic credit (% of GDP) of Latin America(all income levels) in 2012 to that in 2014?
Your answer should be very brief. 0.9. What is the ratio of the Domestic credit (% of GDP) of Afghanistan in 2012 to that in 2014?
Make the answer very short. 1.06. What is the ratio of the Domestic credit (% of GDP) of Australia in 2012 to that in 2014?
Your response must be concise. 0.94. What is the ratio of the Domestic credit (% of GDP) in Fiji in 2012 to that in 2014?
Make the answer very short. 0.95. What is the ratio of the Domestic credit (% of GDP) in Afghanistan in 2013 to that in 2014?
Your answer should be very brief. 1.08. What is the ratio of the Domestic credit (% of GDP) of Australia in 2013 to that in 2014?
Keep it short and to the point. 0.97. What is the ratio of the Domestic credit (% of GDP) of Fiji in 2013 to that in 2014?
Your answer should be compact. 0.96. What is the difference between the highest and the second highest Domestic credit (% of GDP) of Latin America(all income levels)?
Your response must be concise. 1.51. What is the difference between the highest and the second highest Domestic credit (% of GDP) of Australia?
Ensure brevity in your answer.  3.71. What is the difference between the highest and the second highest Domestic credit (% of GDP) of Fiji?
Make the answer very short. 2.33. What is the difference between the highest and the lowest Domestic credit (% of GDP) in Latin America(all income levels)?
Give a very brief answer. 15.17. What is the difference between the highest and the lowest Domestic credit (% of GDP) in Afghanistan?
Give a very brief answer. 7.7. What is the difference between the highest and the lowest Domestic credit (% of GDP) of Australia?
Give a very brief answer. 7.67. What is the difference between the highest and the lowest Domestic credit (% of GDP) of Fiji?
Keep it short and to the point. 7.02. 